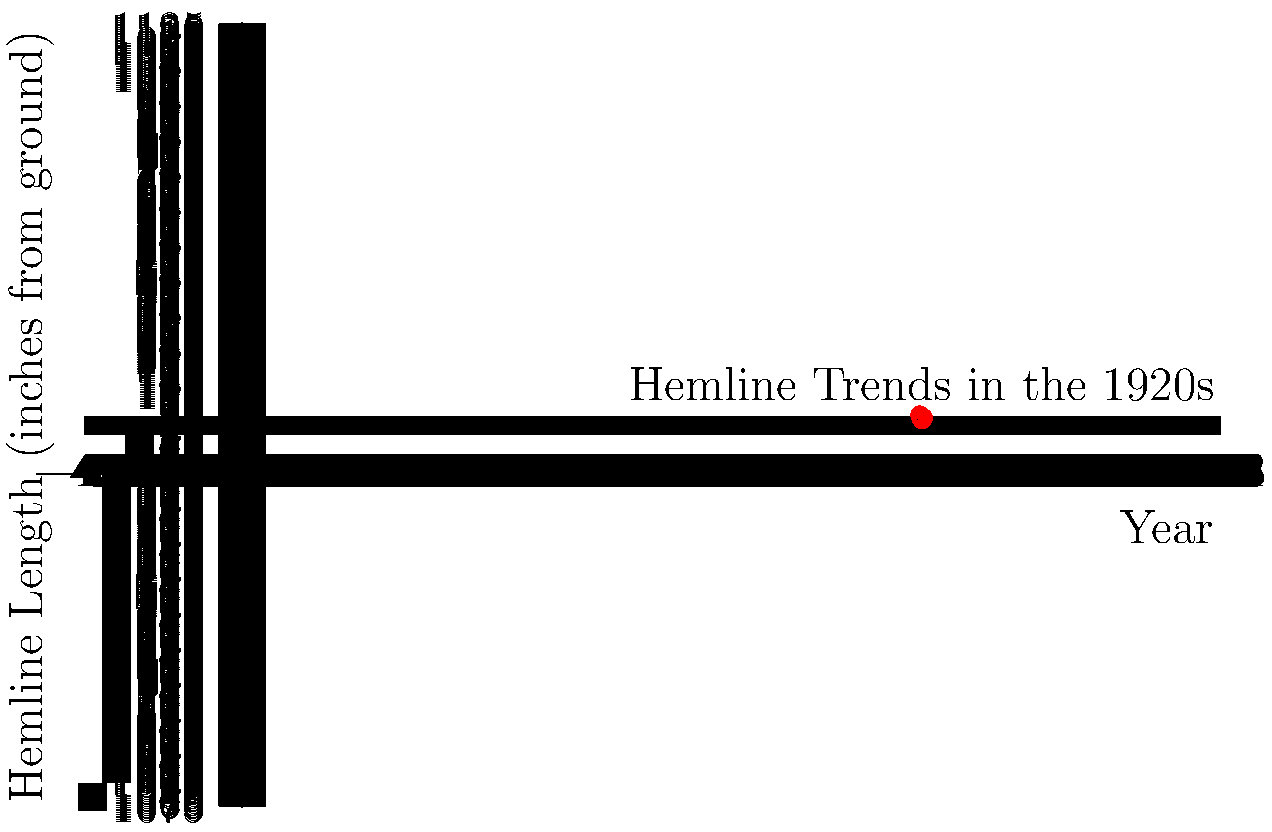In the line graph depicting hemline trends of the 1920s, which year marked the shortest hemline length, capturing the essence of the flapper era's daring fashion revolution? To determine the year with the shortest hemline length, we need to analyze the graph step-by-step:

1. The y-axis represents the hemline length in inches from the ground, while the x-axis shows the years from 1920 to 1930.
2. A lower value on the y-axis indicates a shorter hemline (closer to the ground).
3. Tracing the line from left to right:
   - 1920: Hemline starts around 30 inches
   - 1922: Hemline shortens to about 26 inches
   - 1924: Continues to shorten to approximately 20 inches
   - 1926: Reaches its lowest point at about 16 inches
   - 1928: Begins to lengthen again to around 18 inches
   - 1930: Continues lengthening to about 22 inches

4. The lowest point on the graph, representing the shortest hemline, occurs in 1926.

This trend reflects the pinnacle of the flapper fashion, where hemlines reached their most daring and revolutionary heights (or rather, lows) in the middle of the decade.
Answer: 1926 